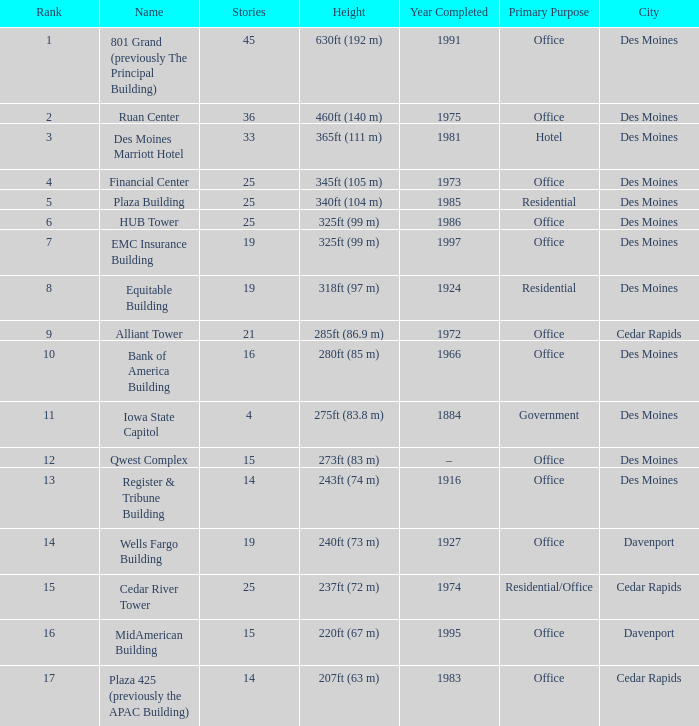What is the cumulative number of stories ranking at 10? 1.0. 